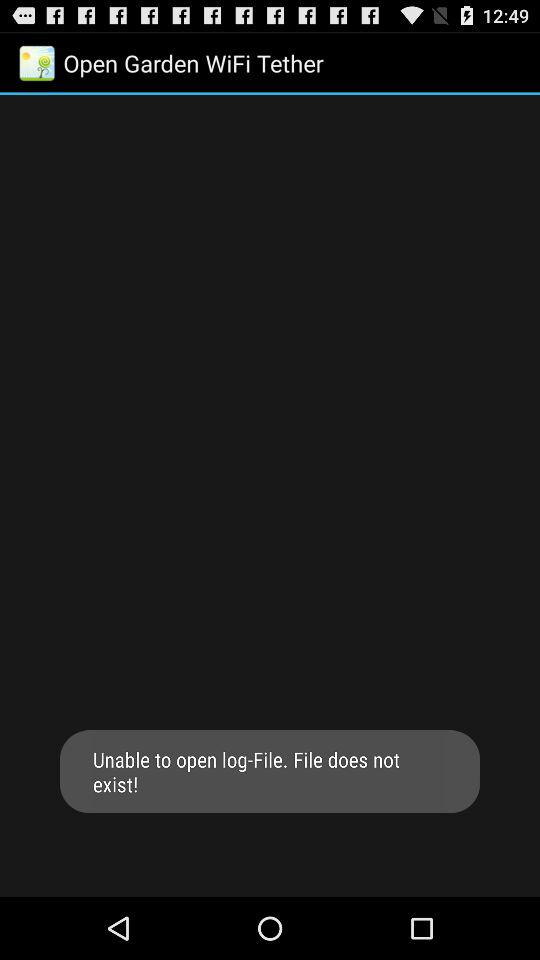What is the user's name?
When the provided information is insufficient, respond with <no answer>. <no answer> 